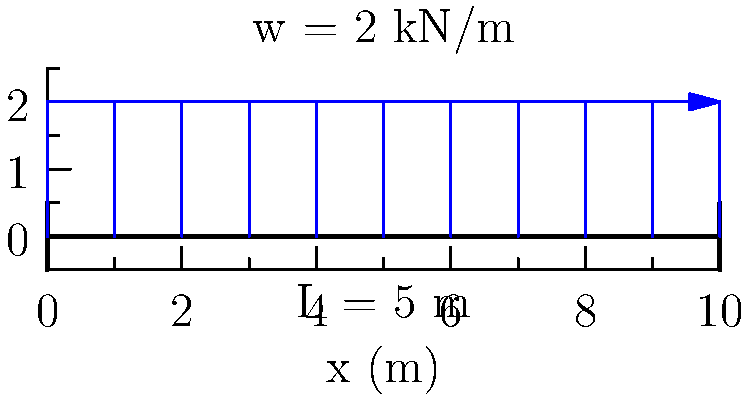Given a simply supported beam of length $L = 5$ m with a uniformly distributed load of $w = 2$ kN/m along its entire length, determine the maximum bending moment in the beam. How does this relate to the fundamental principles of particle physics that you've studied? Let's approach this step-by-step:

1) For a simply supported beam with a uniformly distributed load, the maximum bending moment occurs at the center of the beam.

2) The formula for the maximum bending moment in this case is:

   $$M_{max} = \frac{wL^2}{8}$$

   Where:
   $w$ is the distributed load per unit length
   $L$ is the length of the beam

3) Substituting the given values:
   $w = 2$ kN/m
   $L = 5$ m

4) Calculating:
   $$M_{max} = \frac{2 \cdot 5^2}{8} = \frac{50}{8} = 6.25$$ kN·m

5) Relation to particle physics:
   This problem, while in the domain of civil engineering, shares similarities with concepts in particle physics. The distributed load can be likened to a field in particle physics, where forces are distributed across space. The bending moment represents the cumulative effect of these distributed forces, similar to how fields in particle physics can create potentials that affect particle behavior. The symmetry of the maximum bending moment occurring at the center of the beam is reminiscent of symmetries often observed in particle physics, which play a crucial role in understanding fundamental interactions.
Answer: 6.25 kN·m 